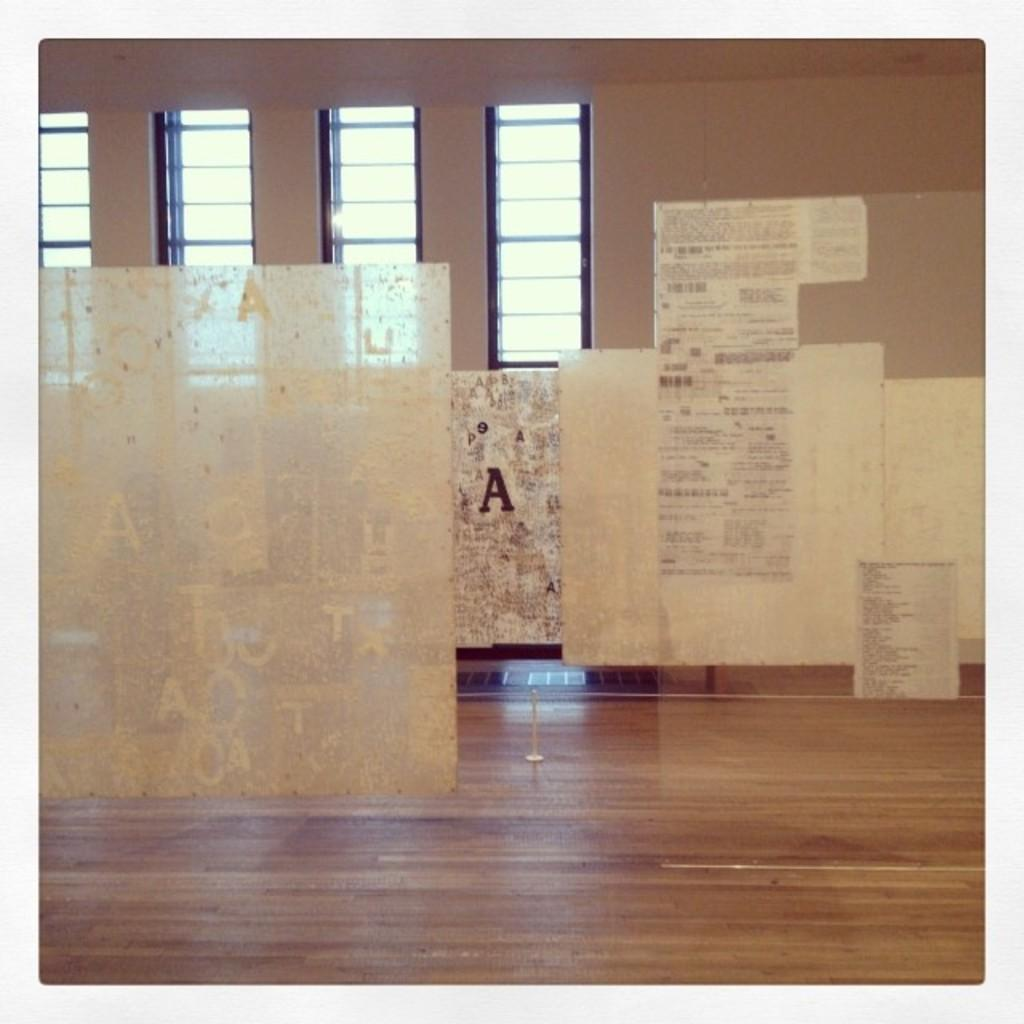What is the main object in the image that has alphabets on it? There is a glass with alphabets on it in the image. What type of glass can be seen in the image? The glass with alphabets is visible in the image. What else can be seen in the image related to glass? There are window glasses visible in the image. What is on the right side of the image? There is a wall on the right side of the image. How much profit can be made from the glass with alphabets in the image? There is no information about profit in the image, as it only shows a glass with alphabets, window glasses, and a wall. 